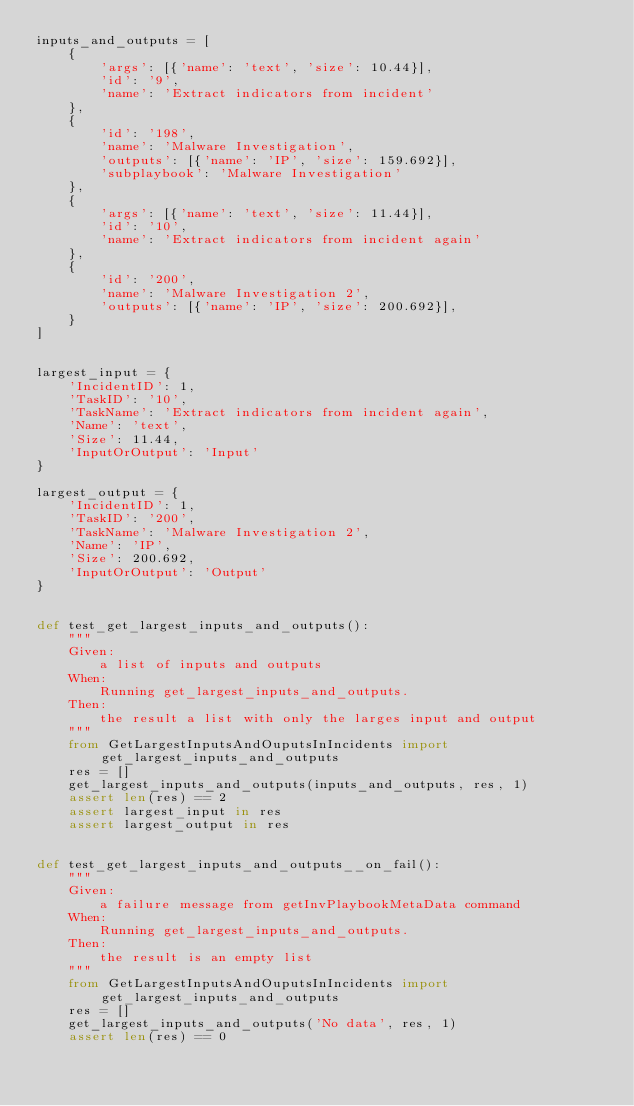<code> <loc_0><loc_0><loc_500><loc_500><_Python_>inputs_and_outputs = [
    {
        'args': [{'name': 'text', 'size': 10.44}],
        'id': '9',
        'name': 'Extract indicators from incident'
    },
    {
        'id': '198',
        'name': 'Malware Investigation',
        'outputs': [{'name': 'IP', 'size': 159.692}],
        'subplaybook': 'Malware Investigation'
    },
    {
        'args': [{'name': 'text', 'size': 11.44}],
        'id': '10',
        'name': 'Extract indicators from incident again'
    },
    {
        'id': '200',
        'name': 'Malware Investigation 2',
        'outputs': [{'name': 'IP', 'size': 200.692}],
    }
]


largest_input = {
    'IncidentID': 1,
    'TaskID': '10',
    'TaskName': 'Extract indicators from incident again',
    'Name': 'text',
    'Size': 11.44,
    'InputOrOutput': 'Input'
}

largest_output = {
    'IncidentID': 1,
    'TaskID': '200',
    'TaskName': 'Malware Investigation 2',
    'Name': 'IP',
    'Size': 200.692,
    'InputOrOutput': 'Output'
}


def test_get_largest_inputs_and_outputs():
    """
    Given:
        a list of inputs and outputs
    When:
        Running get_largest_inputs_and_outputs.
    Then:
        the result a list with only the larges input and output
    """
    from GetLargestInputsAndOuputsInIncidents import get_largest_inputs_and_outputs
    res = []
    get_largest_inputs_and_outputs(inputs_and_outputs, res, 1)
    assert len(res) == 2
    assert largest_input in res
    assert largest_output in res


def test_get_largest_inputs_and_outputs__on_fail():
    """
    Given:
        a failure message from getInvPlaybookMetaData command
    When:
        Running get_largest_inputs_and_outputs.
    Then:
        the result is an empty list
    """
    from GetLargestInputsAndOuputsInIncidents import get_largest_inputs_and_outputs
    res = []
    get_largest_inputs_and_outputs('No data', res, 1)
    assert len(res) == 0
</code> 